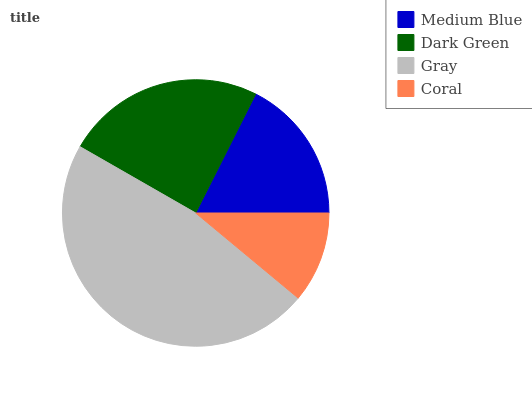Is Coral the minimum?
Answer yes or no. Yes. Is Gray the maximum?
Answer yes or no. Yes. Is Dark Green the minimum?
Answer yes or no. No. Is Dark Green the maximum?
Answer yes or no. No. Is Dark Green greater than Medium Blue?
Answer yes or no. Yes. Is Medium Blue less than Dark Green?
Answer yes or no. Yes. Is Medium Blue greater than Dark Green?
Answer yes or no. No. Is Dark Green less than Medium Blue?
Answer yes or no. No. Is Dark Green the high median?
Answer yes or no. Yes. Is Medium Blue the low median?
Answer yes or no. Yes. Is Gray the high median?
Answer yes or no. No. Is Gray the low median?
Answer yes or no. No. 